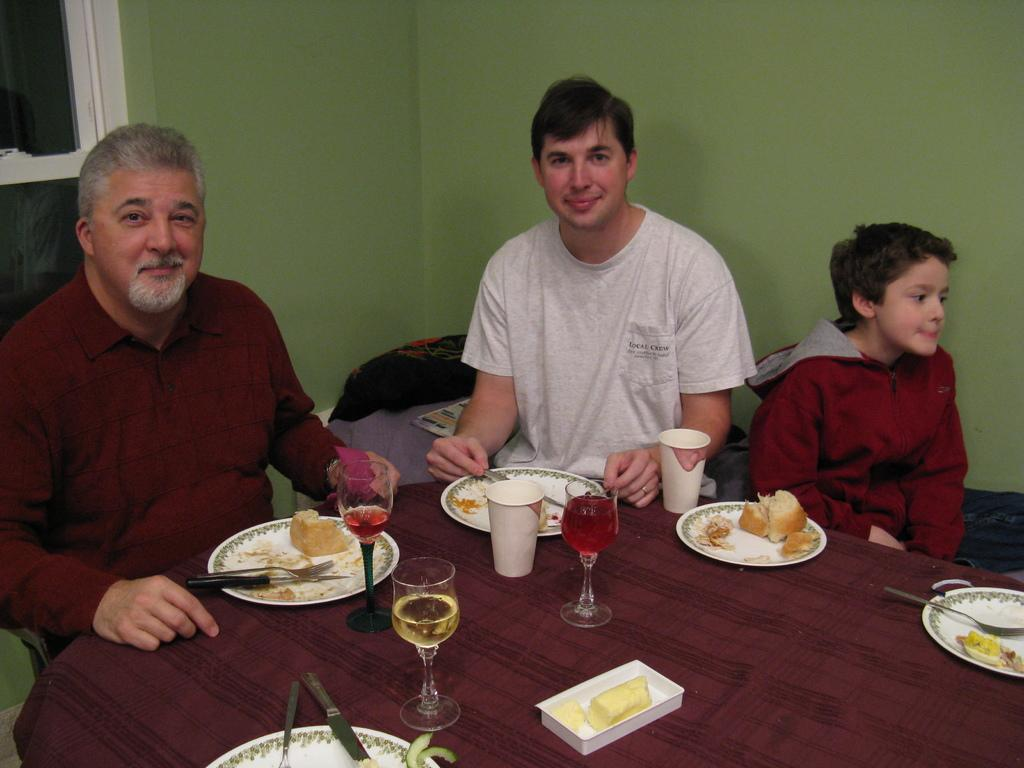What are the people in the image doing? The people in the image are sitting. What is present on the table in the image? There is a table in the image, and there are food items on a plate and glass jars containing liquid on it. What can be seen on the wall in the image? There is a wall in the image, but no specific details about the wall are mentioned in the facts. What is visible through the window in the image? There is a window in the image, but no specific details about what can be seen through it are mentioned in the facts. What objects can be seen in the background of the image? There are objects in the background of the image, but no specific details about them are mentioned in the facts. What type of prose is being recited by the people in the image? There is no mention of prose or any recitation in the image. Are there any bears visible in the image? There are no bears present in the image. 